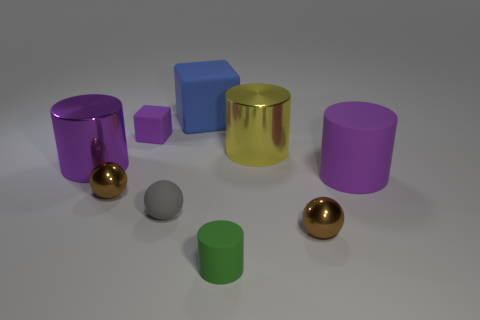What number of other objects are there of the same color as the tiny block?
Make the answer very short. 2. How many spheres are either tiny brown metal objects or green matte things?
Keep it short and to the point. 2. What number of metal things are both in front of the purple matte cylinder and on the right side of the gray sphere?
Provide a short and direct response. 1. There is a matte cylinder in front of the big matte cylinder; what is its color?
Make the answer very short. Green. What is the size of the ball that is the same material as the small block?
Keep it short and to the point. Small. There is a purple thing on the right side of the blue matte object; what number of cylinders are on the right side of it?
Keep it short and to the point. 0. How many tiny gray things are on the left side of the large yellow cylinder?
Ensure brevity in your answer.  1. What color is the shiny cylinder that is on the left side of the tiny brown ball left of the purple matte object that is left of the yellow object?
Make the answer very short. Purple. Do the big metal thing that is on the left side of the big yellow cylinder and the rubber block that is left of the matte sphere have the same color?
Provide a succinct answer. Yes. There is a purple rubber thing to the left of the purple cylinder that is to the right of the tiny matte sphere; what is its shape?
Keep it short and to the point. Cube. 